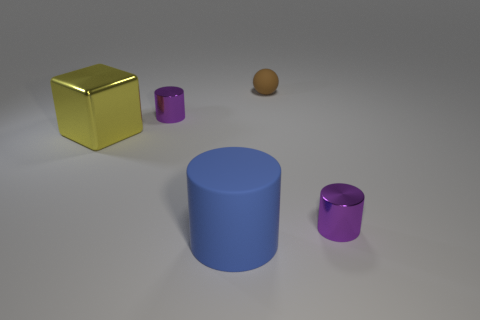Are the thing on the right side of the tiny brown rubber object and the small object to the left of the small rubber sphere made of the same material?
Your response must be concise. Yes. What shape is the matte object that is on the right side of the rubber cylinder?
Offer a terse response. Sphere. Are there fewer brown shiny objects than blue rubber cylinders?
Your answer should be compact. Yes. There is a cylinder behind the tiny cylinder that is right of the big blue matte cylinder; are there any small metal objects that are to the left of it?
Ensure brevity in your answer.  No. How many metal things are either tiny purple objects or brown balls?
Ensure brevity in your answer.  2. Do the large rubber object and the sphere have the same color?
Your answer should be very brief. No. There is a large yellow metallic thing; what number of cylinders are in front of it?
Provide a short and direct response. 2. What number of tiny purple objects are both to the right of the large blue matte cylinder and left of the tiny matte object?
Make the answer very short. 0. There is a blue thing that is the same material as the tiny sphere; what is its shape?
Ensure brevity in your answer.  Cylinder. Do the purple cylinder in front of the big shiny cube and the purple cylinder that is left of the blue rubber cylinder have the same size?
Make the answer very short. Yes. 